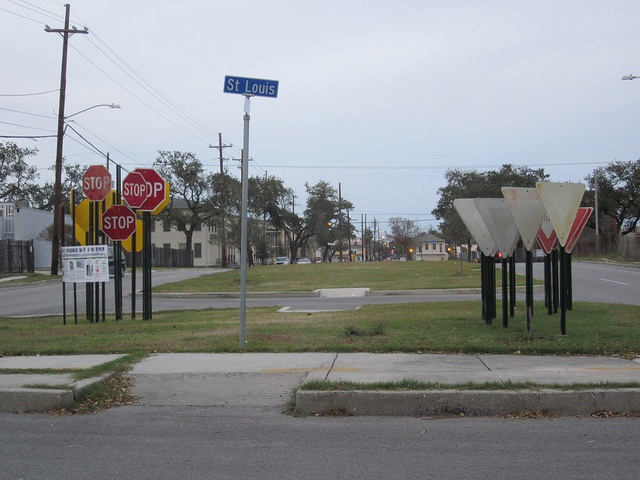Describe the objects in this image and their specific colors. I can see stop sign in lavender, maroon, gray, and brown tones, stop sign in lavender, maroon, darkgray, gray, and brown tones, stop sign in lavender and brown tones, stop sign in lavender, brown, darkgray, and gray tones, and stop sign in lavender and olive tones in this image. 